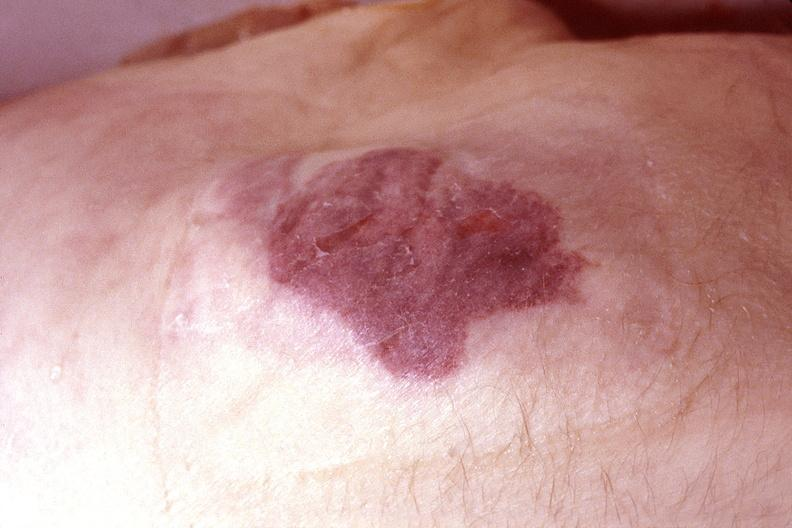does micrognathia triploid fetus show skin, kaposis 's sarcoma?
Answer the question using a single word or phrase. No 